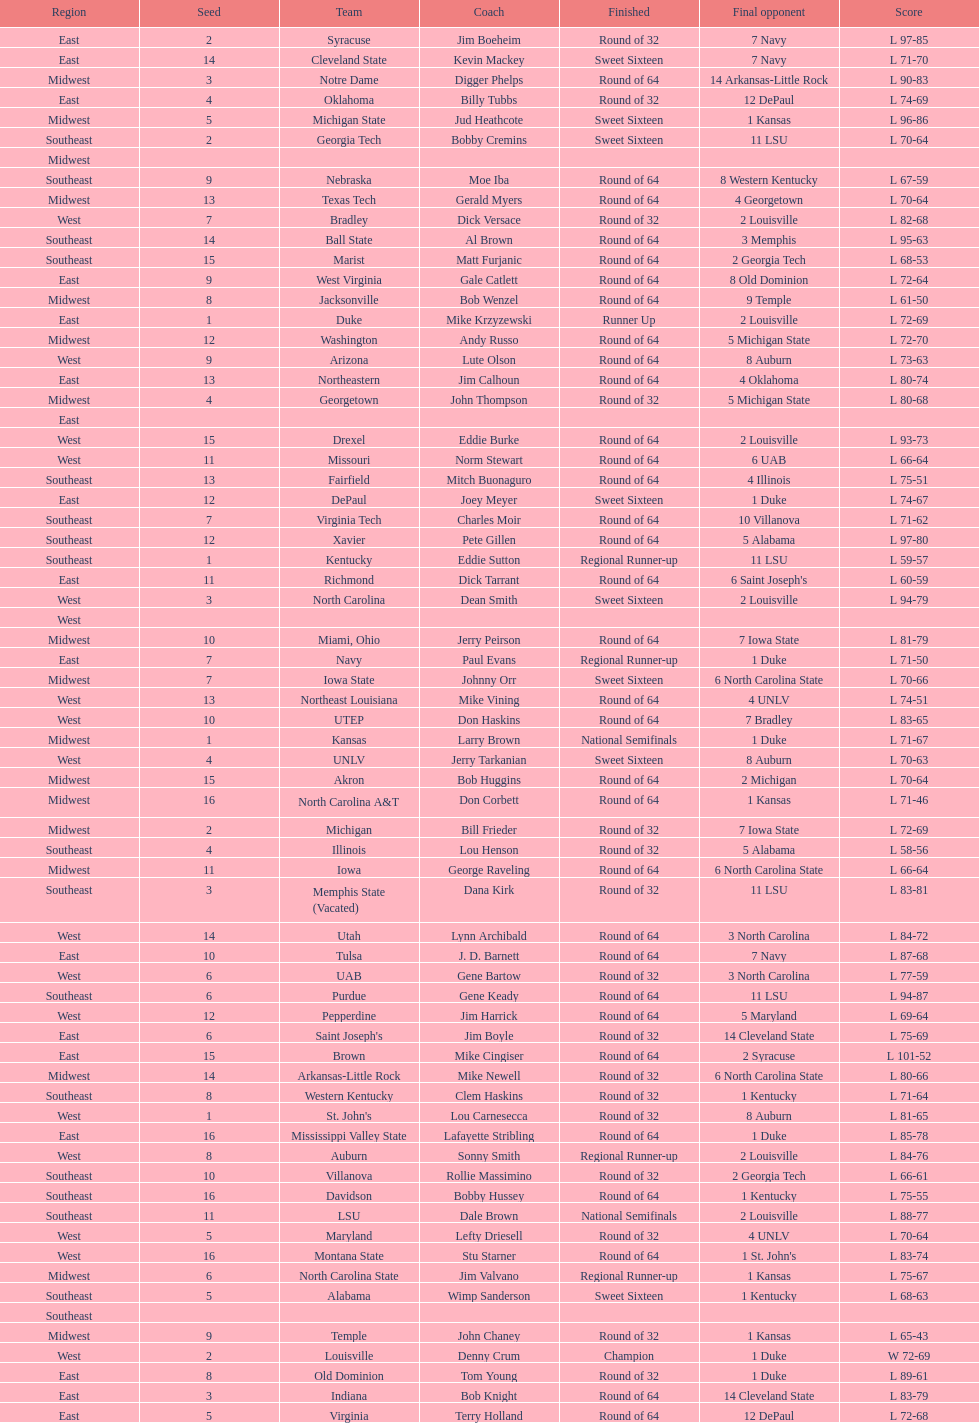Who is the only team from the east region to reach the final round? Duke. 